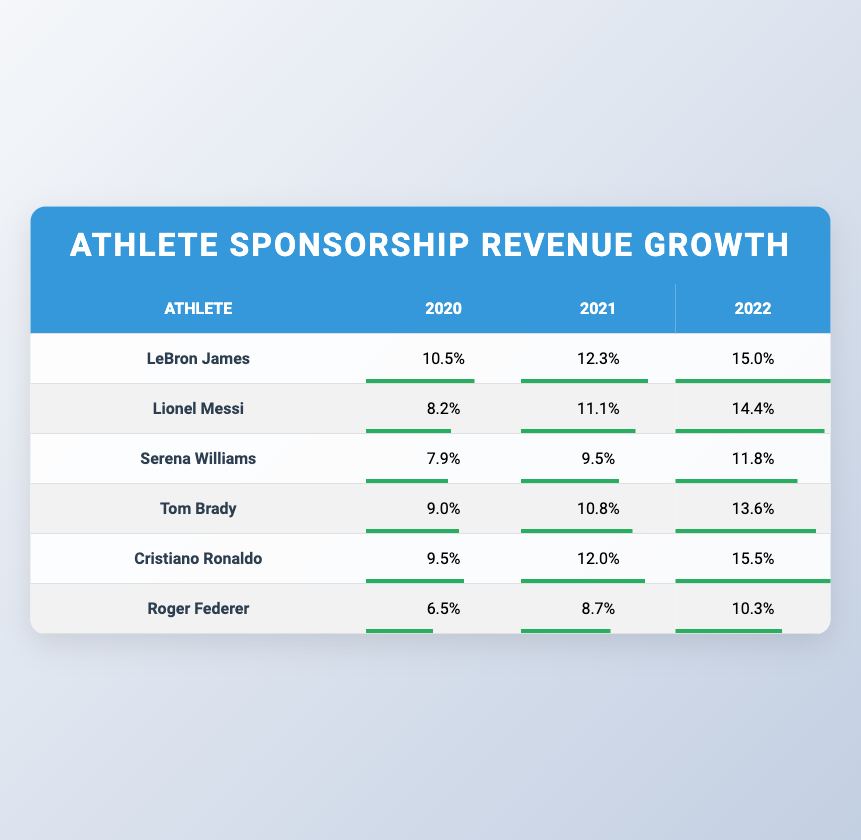What was LeBron James' sponsorship revenue growth percentage in 2021? According to the table, LeBron James had a revenue growth percentage of 12.3% in 2021.
Answer: 12.3% Which athlete had the highest revenue growth percentage in 2022? The table shows that Cristiano Ronaldo had the highest revenue growth percentage of 15.5% in 2022.
Answer: Cristiano Ronaldo What is the average revenue growth percentage for Serena Williams from 2020 to 2022? Serena Williams' revenue growth percentages are 7.9% (2020), 9.5% (2021), and 11.8% (2022). The sum is 7.9 + 9.5 + 11.8 = 29.2%. There are 3 years, so to find the average, divide 29.2% by 3, which equals 9.73%.
Answer: 9.73% Did Tom Brady's revenue growth percentage increase every year from 2020 to 2022? By examining the table, we can see that Tom Brady's revenue growth percentages are 9.0% (2020), 10.8% (2021), and 13.6% (2022), indicating an increase each year.
Answer: Yes What was the difference in revenue growth percentage between Cristiano Ronaldo and Roger Federer in 2020? Cristiano Ronaldo had a revenue growth percentage of 9.5% and Roger Federer had 6.5% in 2020. The difference is 9.5% - 6.5% = 3%.
Answer: 3% Which athlete had the lowest revenue growth percentage in 2020, and what was that percentage? The table shows that Roger Federer had the lowest revenue growth percentage of 6.5% in 2020.
Answer: Roger Federer, 6.5% What was the total revenue growth percentage for Lionel Messi over the three years combined? Lionel Messi's revenue growth percentages are 8.2% (2020), 11.1% (2021), and 14.4% (2022). The total is 8.2 + 11.1 + 14.4 = 33.7%.
Answer: 33.7% Did any athlete consistently have more than 10% revenue growth in every year from 2020 to 2022? By checking the table, LeBron James (12.3% in 2021 and 15.0% in 2022) and Cristiano Ronaldo (12.0% in 2021 and 15.5% in 2022) had numbers over 10% in both years they are present; however, in 2020 both had percentages under 10%, thus no athlete met this requirement for all three years.
Answer: No Which two athletes had a revenue growth percentage of 12.0% in 2021? The table lists Cristiano Ronaldo and LeBron James with percentages of 12.0% and 12.3%, respectively, but only Cristiano Ronaldo exactly reached 12.0%.
Answer: Cristiano Ronaldo What was the growth percentage for Roger Federer in 2022 compared to his percentage in 2021? Roger Federer's revenue growth was 10.3% in 2022 and 8.7% in 2021. The increase is calculated as 10.3% - 8.7% = 1.6%.
Answer: 1.6% 